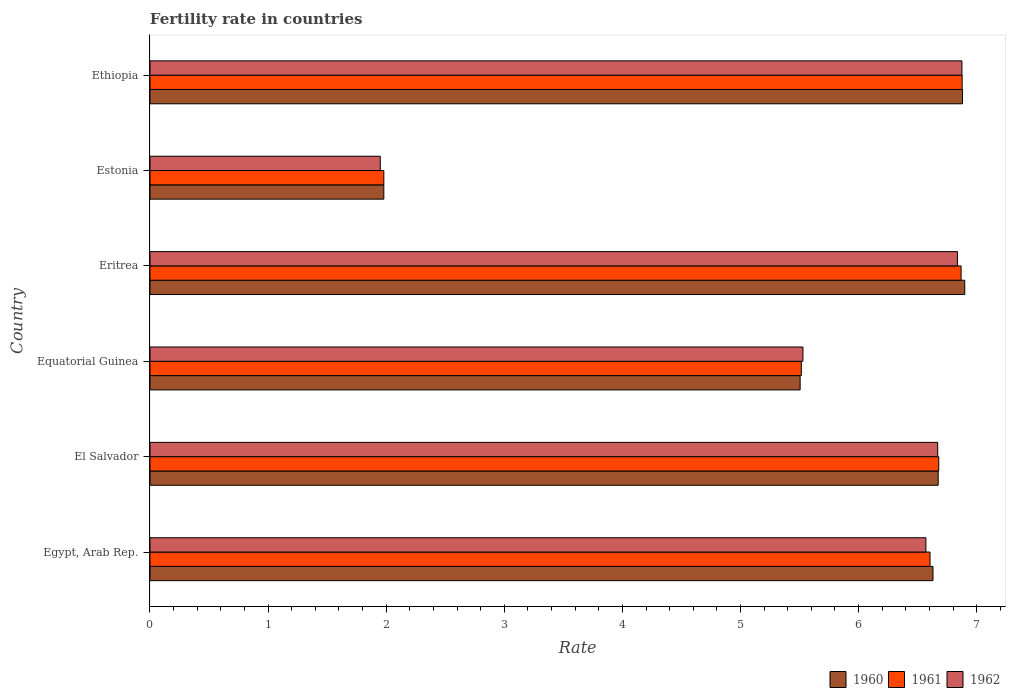Are the number of bars per tick equal to the number of legend labels?
Provide a succinct answer. Yes. How many bars are there on the 6th tick from the top?
Make the answer very short. 3. How many bars are there on the 6th tick from the bottom?
Your answer should be very brief. 3. What is the label of the 3rd group of bars from the top?
Offer a terse response. Eritrea. In how many cases, is the number of bars for a given country not equal to the number of legend labels?
Ensure brevity in your answer.  0. What is the fertility rate in 1960 in Equatorial Guinea?
Keep it short and to the point. 5.5. Across all countries, what is the maximum fertility rate in 1960?
Your response must be concise. 6.9. Across all countries, what is the minimum fertility rate in 1961?
Your answer should be compact. 1.98. In which country was the fertility rate in 1961 maximum?
Keep it short and to the point. Ethiopia. In which country was the fertility rate in 1961 minimum?
Provide a succinct answer. Estonia. What is the total fertility rate in 1962 in the graph?
Give a very brief answer. 34.43. What is the difference between the fertility rate in 1961 in Eritrea and that in Ethiopia?
Keep it short and to the point. -0.01. What is the difference between the fertility rate in 1961 in Equatorial Guinea and the fertility rate in 1962 in Ethiopia?
Offer a very short reply. -1.36. What is the average fertility rate in 1961 per country?
Give a very brief answer. 5.75. What is the difference between the fertility rate in 1960 and fertility rate in 1962 in Estonia?
Ensure brevity in your answer.  0.03. What is the ratio of the fertility rate in 1961 in Eritrea to that in Ethiopia?
Give a very brief answer. 1. Is the fertility rate in 1961 in Eritrea less than that in Estonia?
Your response must be concise. No. Is the difference between the fertility rate in 1960 in Estonia and Ethiopia greater than the difference between the fertility rate in 1962 in Estonia and Ethiopia?
Give a very brief answer. Yes. What is the difference between the highest and the second highest fertility rate in 1960?
Offer a terse response. 0.02. What is the difference between the highest and the lowest fertility rate in 1960?
Provide a succinct answer. 4.92. In how many countries, is the fertility rate in 1961 greater than the average fertility rate in 1961 taken over all countries?
Offer a terse response. 4. Is the sum of the fertility rate in 1960 in El Salvador and Equatorial Guinea greater than the maximum fertility rate in 1962 across all countries?
Ensure brevity in your answer.  Yes. What does the 3rd bar from the top in Egypt, Arab Rep. represents?
Your answer should be compact. 1960. How many countries are there in the graph?
Your answer should be very brief. 6. Are the values on the major ticks of X-axis written in scientific E-notation?
Your answer should be very brief. No. Does the graph contain grids?
Your answer should be compact. No. Where does the legend appear in the graph?
Offer a very short reply. Bottom right. How many legend labels are there?
Offer a very short reply. 3. How are the legend labels stacked?
Provide a succinct answer. Horizontal. What is the title of the graph?
Keep it short and to the point. Fertility rate in countries. What is the label or title of the X-axis?
Keep it short and to the point. Rate. What is the Rate in 1960 in Egypt, Arab Rep.?
Offer a very short reply. 6.63. What is the Rate of 1961 in Egypt, Arab Rep.?
Offer a very short reply. 6.61. What is the Rate of 1962 in Egypt, Arab Rep.?
Your response must be concise. 6.57. What is the Rate of 1960 in El Salvador?
Offer a terse response. 6.67. What is the Rate of 1961 in El Salvador?
Provide a succinct answer. 6.68. What is the Rate of 1962 in El Salvador?
Keep it short and to the point. 6.67. What is the Rate of 1960 in Equatorial Guinea?
Make the answer very short. 5.5. What is the Rate of 1961 in Equatorial Guinea?
Offer a terse response. 5.51. What is the Rate in 1962 in Equatorial Guinea?
Ensure brevity in your answer.  5.53. What is the Rate of 1960 in Eritrea?
Make the answer very short. 6.9. What is the Rate of 1961 in Eritrea?
Offer a very short reply. 6.87. What is the Rate of 1962 in Eritrea?
Your response must be concise. 6.84. What is the Rate in 1960 in Estonia?
Give a very brief answer. 1.98. What is the Rate in 1961 in Estonia?
Give a very brief answer. 1.98. What is the Rate of 1962 in Estonia?
Your answer should be compact. 1.95. What is the Rate in 1960 in Ethiopia?
Make the answer very short. 6.88. What is the Rate of 1961 in Ethiopia?
Provide a succinct answer. 6.88. What is the Rate of 1962 in Ethiopia?
Offer a very short reply. 6.88. Across all countries, what is the maximum Rate in 1960?
Provide a short and direct response. 6.9. Across all countries, what is the maximum Rate in 1961?
Your answer should be very brief. 6.88. Across all countries, what is the maximum Rate in 1962?
Your answer should be compact. 6.88. Across all countries, what is the minimum Rate of 1960?
Provide a short and direct response. 1.98. Across all countries, what is the minimum Rate of 1961?
Your answer should be compact. 1.98. Across all countries, what is the minimum Rate of 1962?
Make the answer very short. 1.95. What is the total Rate in 1960 in the graph?
Your answer should be very brief. 34.57. What is the total Rate in 1961 in the graph?
Your response must be concise. 34.52. What is the total Rate of 1962 in the graph?
Keep it short and to the point. 34.43. What is the difference between the Rate in 1960 in Egypt, Arab Rep. and that in El Salvador?
Offer a very short reply. -0.04. What is the difference between the Rate in 1961 in Egypt, Arab Rep. and that in El Salvador?
Offer a very short reply. -0.07. What is the difference between the Rate in 1962 in Egypt, Arab Rep. and that in El Salvador?
Provide a short and direct response. -0.1. What is the difference between the Rate in 1961 in Egypt, Arab Rep. and that in Equatorial Guinea?
Offer a terse response. 1.09. What is the difference between the Rate of 1962 in Egypt, Arab Rep. and that in Equatorial Guinea?
Your response must be concise. 1.04. What is the difference between the Rate of 1960 in Egypt, Arab Rep. and that in Eritrea?
Offer a very short reply. -0.27. What is the difference between the Rate in 1961 in Egypt, Arab Rep. and that in Eritrea?
Offer a very short reply. -0.26. What is the difference between the Rate of 1962 in Egypt, Arab Rep. and that in Eritrea?
Make the answer very short. -0.27. What is the difference between the Rate of 1960 in Egypt, Arab Rep. and that in Estonia?
Ensure brevity in your answer.  4.65. What is the difference between the Rate of 1961 in Egypt, Arab Rep. and that in Estonia?
Keep it short and to the point. 4.62. What is the difference between the Rate of 1962 in Egypt, Arab Rep. and that in Estonia?
Ensure brevity in your answer.  4.62. What is the difference between the Rate of 1961 in Egypt, Arab Rep. and that in Ethiopia?
Offer a very short reply. -0.27. What is the difference between the Rate in 1962 in Egypt, Arab Rep. and that in Ethiopia?
Provide a succinct answer. -0.3. What is the difference between the Rate of 1960 in El Salvador and that in Equatorial Guinea?
Provide a short and direct response. 1.17. What is the difference between the Rate in 1961 in El Salvador and that in Equatorial Guinea?
Your answer should be compact. 1.16. What is the difference between the Rate in 1962 in El Salvador and that in Equatorial Guinea?
Your answer should be very brief. 1.14. What is the difference between the Rate in 1960 in El Salvador and that in Eritrea?
Offer a terse response. -0.23. What is the difference between the Rate of 1961 in El Salvador and that in Eritrea?
Make the answer very short. -0.19. What is the difference between the Rate in 1962 in El Salvador and that in Eritrea?
Your answer should be very brief. -0.17. What is the difference between the Rate of 1960 in El Salvador and that in Estonia?
Provide a succinct answer. 4.69. What is the difference between the Rate in 1961 in El Salvador and that in Estonia?
Your answer should be compact. 4.7. What is the difference between the Rate of 1962 in El Salvador and that in Estonia?
Keep it short and to the point. 4.72. What is the difference between the Rate in 1960 in El Salvador and that in Ethiopia?
Provide a short and direct response. -0.21. What is the difference between the Rate in 1961 in El Salvador and that in Ethiopia?
Your response must be concise. -0.2. What is the difference between the Rate in 1962 in El Salvador and that in Ethiopia?
Make the answer very short. -0.2. What is the difference between the Rate of 1960 in Equatorial Guinea and that in Eritrea?
Ensure brevity in your answer.  -1.39. What is the difference between the Rate in 1961 in Equatorial Guinea and that in Eritrea?
Your answer should be very brief. -1.35. What is the difference between the Rate of 1962 in Equatorial Guinea and that in Eritrea?
Give a very brief answer. -1.31. What is the difference between the Rate in 1960 in Equatorial Guinea and that in Estonia?
Provide a short and direct response. 3.52. What is the difference between the Rate of 1961 in Equatorial Guinea and that in Estonia?
Your response must be concise. 3.54. What is the difference between the Rate of 1962 in Equatorial Guinea and that in Estonia?
Give a very brief answer. 3.58. What is the difference between the Rate in 1960 in Equatorial Guinea and that in Ethiopia?
Provide a succinct answer. -1.38. What is the difference between the Rate in 1961 in Equatorial Guinea and that in Ethiopia?
Make the answer very short. -1.36. What is the difference between the Rate of 1962 in Equatorial Guinea and that in Ethiopia?
Keep it short and to the point. -1.35. What is the difference between the Rate in 1960 in Eritrea and that in Estonia?
Offer a very short reply. 4.92. What is the difference between the Rate of 1961 in Eritrea and that in Estonia?
Keep it short and to the point. 4.89. What is the difference between the Rate of 1962 in Eritrea and that in Estonia?
Keep it short and to the point. 4.89. What is the difference between the Rate in 1960 in Eritrea and that in Ethiopia?
Ensure brevity in your answer.  0.02. What is the difference between the Rate of 1961 in Eritrea and that in Ethiopia?
Your answer should be compact. -0.01. What is the difference between the Rate in 1962 in Eritrea and that in Ethiopia?
Your answer should be compact. -0.04. What is the difference between the Rate in 1961 in Estonia and that in Ethiopia?
Give a very brief answer. -4.9. What is the difference between the Rate in 1962 in Estonia and that in Ethiopia?
Provide a short and direct response. -4.92. What is the difference between the Rate in 1960 in Egypt, Arab Rep. and the Rate in 1961 in El Salvador?
Keep it short and to the point. -0.05. What is the difference between the Rate of 1960 in Egypt, Arab Rep. and the Rate of 1962 in El Salvador?
Your answer should be compact. -0.04. What is the difference between the Rate of 1961 in Egypt, Arab Rep. and the Rate of 1962 in El Salvador?
Your answer should be compact. -0.07. What is the difference between the Rate of 1960 in Egypt, Arab Rep. and the Rate of 1961 in Equatorial Guinea?
Give a very brief answer. 1.11. What is the difference between the Rate in 1960 in Egypt, Arab Rep. and the Rate in 1962 in Equatorial Guinea?
Ensure brevity in your answer.  1.1. What is the difference between the Rate in 1961 in Egypt, Arab Rep. and the Rate in 1962 in Equatorial Guinea?
Your response must be concise. 1.08. What is the difference between the Rate in 1960 in Egypt, Arab Rep. and the Rate in 1961 in Eritrea?
Your answer should be very brief. -0.24. What is the difference between the Rate in 1960 in Egypt, Arab Rep. and the Rate in 1962 in Eritrea?
Offer a very short reply. -0.21. What is the difference between the Rate of 1961 in Egypt, Arab Rep. and the Rate of 1962 in Eritrea?
Your answer should be compact. -0.23. What is the difference between the Rate of 1960 in Egypt, Arab Rep. and the Rate of 1961 in Estonia?
Make the answer very short. 4.65. What is the difference between the Rate in 1960 in Egypt, Arab Rep. and the Rate in 1962 in Estonia?
Provide a succinct answer. 4.68. What is the difference between the Rate of 1961 in Egypt, Arab Rep. and the Rate of 1962 in Estonia?
Provide a succinct answer. 4.66. What is the difference between the Rate of 1960 in Egypt, Arab Rep. and the Rate of 1961 in Ethiopia?
Make the answer very short. -0.25. What is the difference between the Rate in 1960 in Egypt, Arab Rep. and the Rate in 1962 in Ethiopia?
Offer a terse response. -0.24. What is the difference between the Rate of 1961 in Egypt, Arab Rep. and the Rate of 1962 in Ethiopia?
Offer a very short reply. -0.27. What is the difference between the Rate in 1960 in El Salvador and the Rate in 1961 in Equatorial Guinea?
Provide a succinct answer. 1.16. What is the difference between the Rate of 1960 in El Salvador and the Rate of 1962 in Equatorial Guinea?
Keep it short and to the point. 1.15. What is the difference between the Rate of 1961 in El Salvador and the Rate of 1962 in Equatorial Guinea?
Provide a succinct answer. 1.15. What is the difference between the Rate in 1960 in El Salvador and the Rate in 1961 in Eritrea?
Provide a succinct answer. -0.19. What is the difference between the Rate in 1960 in El Salvador and the Rate in 1962 in Eritrea?
Offer a very short reply. -0.16. What is the difference between the Rate in 1961 in El Salvador and the Rate in 1962 in Eritrea?
Your response must be concise. -0.16. What is the difference between the Rate of 1960 in El Salvador and the Rate of 1961 in Estonia?
Ensure brevity in your answer.  4.69. What is the difference between the Rate of 1960 in El Salvador and the Rate of 1962 in Estonia?
Offer a terse response. 4.72. What is the difference between the Rate in 1961 in El Salvador and the Rate in 1962 in Estonia?
Your response must be concise. 4.73. What is the difference between the Rate in 1960 in El Salvador and the Rate in 1961 in Ethiopia?
Offer a terse response. -0.2. What is the difference between the Rate in 1960 in El Salvador and the Rate in 1962 in Ethiopia?
Offer a terse response. -0.2. What is the difference between the Rate in 1961 in El Salvador and the Rate in 1962 in Ethiopia?
Ensure brevity in your answer.  -0.2. What is the difference between the Rate in 1960 in Equatorial Guinea and the Rate in 1961 in Eritrea?
Offer a terse response. -1.36. What is the difference between the Rate in 1960 in Equatorial Guinea and the Rate in 1962 in Eritrea?
Give a very brief answer. -1.33. What is the difference between the Rate of 1961 in Equatorial Guinea and the Rate of 1962 in Eritrea?
Make the answer very short. -1.32. What is the difference between the Rate in 1960 in Equatorial Guinea and the Rate in 1961 in Estonia?
Offer a terse response. 3.52. What is the difference between the Rate in 1960 in Equatorial Guinea and the Rate in 1962 in Estonia?
Keep it short and to the point. 3.56. What is the difference between the Rate in 1961 in Equatorial Guinea and the Rate in 1962 in Estonia?
Provide a succinct answer. 3.56. What is the difference between the Rate of 1960 in Equatorial Guinea and the Rate of 1961 in Ethiopia?
Provide a succinct answer. -1.37. What is the difference between the Rate in 1960 in Equatorial Guinea and the Rate in 1962 in Ethiopia?
Provide a succinct answer. -1.37. What is the difference between the Rate of 1961 in Equatorial Guinea and the Rate of 1962 in Ethiopia?
Provide a short and direct response. -1.36. What is the difference between the Rate of 1960 in Eritrea and the Rate of 1961 in Estonia?
Your answer should be compact. 4.92. What is the difference between the Rate in 1960 in Eritrea and the Rate in 1962 in Estonia?
Offer a very short reply. 4.95. What is the difference between the Rate of 1961 in Eritrea and the Rate of 1962 in Estonia?
Your answer should be compact. 4.92. What is the difference between the Rate in 1960 in Eritrea and the Rate in 1961 in Ethiopia?
Your answer should be compact. 0.02. What is the difference between the Rate in 1960 in Eritrea and the Rate in 1962 in Ethiopia?
Your answer should be compact. 0.02. What is the difference between the Rate of 1961 in Eritrea and the Rate of 1962 in Ethiopia?
Your answer should be very brief. -0.01. What is the difference between the Rate in 1960 in Estonia and the Rate in 1961 in Ethiopia?
Your answer should be compact. -4.9. What is the difference between the Rate of 1960 in Estonia and the Rate of 1962 in Ethiopia?
Offer a very short reply. -4.89. What is the difference between the Rate in 1961 in Estonia and the Rate in 1962 in Ethiopia?
Ensure brevity in your answer.  -4.89. What is the average Rate of 1960 per country?
Your answer should be compact. 5.76. What is the average Rate in 1961 per country?
Your answer should be very brief. 5.75. What is the average Rate of 1962 per country?
Make the answer very short. 5.74. What is the difference between the Rate in 1960 and Rate in 1961 in Egypt, Arab Rep.?
Your answer should be compact. 0.03. What is the difference between the Rate of 1961 and Rate of 1962 in Egypt, Arab Rep.?
Give a very brief answer. 0.04. What is the difference between the Rate of 1960 and Rate of 1961 in El Salvador?
Offer a terse response. -0.01. What is the difference between the Rate in 1960 and Rate in 1962 in El Salvador?
Keep it short and to the point. 0. What is the difference between the Rate in 1961 and Rate in 1962 in El Salvador?
Your answer should be compact. 0.01. What is the difference between the Rate of 1960 and Rate of 1961 in Equatorial Guinea?
Offer a terse response. -0.01. What is the difference between the Rate in 1960 and Rate in 1962 in Equatorial Guinea?
Offer a terse response. -0.02. What is the difference between the Rate in 1961 and Rate in 1962 in Equatorial Guinea?
Offer a terse response. -0.01. What is the difference between the Rate in 1960 and Rate in 1961 in Eritrea?
Offer a terse response. 0.03. What is the difference between the Rate of 1960 and Rate of 1962 in Eritrea?
Your answer should be very brief. 0.06. What is the difference between the Rate of 1961 and Rate of 1962 in Eritrea?
Keep it short and to the point. 0.03. What is the difference between the Rate of 1960 and Rate of 1962 in Estonia?
Make the answer very short. 0.03. What is the difference between the Rate of 1961 and Rate of 1962 in Estonia?
Provide a succinct answer. 0.03. What is the difference between the Rate in 1960 and Rate in 1961 in Ethiopia?
Ensure brevity in your answer.  0. What is the difference between the Rate in 1960 and Rate in 1962 in Ethiopia?
Keep it short and to the point. 0.01. What is the difference between the Rate in 1961 and Rate in 1962 in Ethiopia?
Offer a terse response. 0. What is the ratio of the Rate of 1961 in Egypt, Arab Rep. to that in El Salvador?
Provide a short and direct response. 0.99. What is the ratio of the Rate of 1960 in Egypt, Arab Rep. to that in Equatorial Guinea?
Provide a succinct answer. 1.2. What is the ratio of the Rate of 1961 in Egypt, Arab Rep. to that in Equatorial Guinea?
Provide a short and direct response. 1.2. What is the ratio of the Rate in 1962 in Egypt, Arab Rep. to that in Equatorial Guinea?
Your answer should be very brief. 1.19. What is the ratio of the Rate in 1960 in Egypt, Arab Rep. to that in Eritrea?
Provide a short and direct response. 0.96. What is the ratio of the Rate of 1961 in Egypt, Arab Rep. to that in Eritrea?
Your answer should be compact. 0.96. What is the ratio of the Rate of 1962 in Egypt, Arab Rep. to that in Eritrea?
Offer a terse response. 0.96. What is the ratio of the Rate of 1960 in Egypt, Arab Rep. to that in Estonia?
Your answer should be very brief. 3.35. What is the ratio of the Rate of 1961 in Egypt, Arab Rep. to that in Estonia?
Provide a short and direct response. 3.34. What is the ratio of the Rate of 1962 in Egypt, Arab Rep. to that in Estonia?
Make the answer very short. 3.37. What is the ratio of the Rate of 1960 in Egypt, Arab Rep. to that in Ethiopia?
Your response must be concise. 0.96. What is the ratio of the Rate in 1961 in Egypt, Arab Rep. to that in Ethiopia?
Provide a succinct answer. 0.96. What is the ratio of the Rate of 1962 in Egypt, Arab Rep. to that in Ethiopia?
Your answer should be very brief. 0.96. What is the ratio of the Rate in 1960 in El Salvador to that in Equatorial Guinea?
Your response must be concise. 1.21. What is the ratio of the Rate of 1961 in El Salvador to that in Equatorial Guinea?
Your response must be concise. 1.21. What is the ratio of the Rate of 1962 in El Salvador to that in Equatorial Guinea?
Offer a terse response. 1.21. What is the ratio of the Rate in 1960 in El Salvador to that in Eritrea?
Keep it short and to the point. 0.97. What is the ratio of the Rate of 1961 in El Salvador to that in Eritrea?
Keep it short and to the point. 0.97. What is the ratio of the Rate in 1962 in El Salvador to that in Eritrea?
Give a very brief answer. 0.98. What is the ratio of the Rate in 1960 in El Salvador to that in Estonia?
Make the answer very short. 3.37. What is the ratio of the Rate in 1961 in El Salvador to that in Estonia?
Your answer should be compact. 3.37. What is the ratio of the Rate in 1962 in El Salvador to that in Estonia?
Your answer should be compact. 3.42. What is the ratio of the Rate of 1960 in El Salvador to that in Ethiopia?
Ensure brevity in your answer.  0.97. What is the ratio of the Rate of 1961 in El Salvador to that in Ethiopia?
Provide a short and direct response. 0.97. What is the ratio of the Rate in 1962 in El Salvador to that in Ethiopia?
Offer a terse response. 0.97. What is the ratio of the Rate of 1960 in Equatorial Guinea to that in Eritrea?
Your answer should be very brief. 0.8. What is the ratio of the Rate in 1961 in Equatorial Guinea to that in Eritrea?
Make the answer very short. 0.8. What is the ratio of the Rate in 1962 in Equatorial Guinea to that in Eritrea?
Provide a short and direct response. 0.81. What is the ratio of the Rate of 1960 in Equatorial Guinea to that in Estonia?
Your answer should be very brief. 2.78. What is the ratio of the Rate in 1961 in Equatorial Guinea to that in Estonia?
Your answer should be very brief. 2.79. What is the ratio of the Rate of 1962 in Equatorial Guinea to that in Estonia?
Ensure brevity in your answer.  2.84. What is the ratio of the Rate in 1960 in Equatorial Guinea to that in Ethiopia?
Make the answer very short. 0.8. What is the ratio of the Rate of 1961 in Equatorial Guinea to that in Ethiopia?
Your response must be concise. 0.8. What is the ratio of the Rate in 1962 in Equatorial Guinea to that in Ethiopia?
Keep it short and to the point. 0.8. What is the ratio of the Rate of 1960 in Eritrea to that in Estonia?
Keep it short and to the point. 3.48. What is the ratio of the Rate in 1961 in Eritrea to that in Estonia?
Make the answer very short. 3.47. What is the ratio of the Rate of 1962 in Eritrea to that in Estonia?
Make the answer very short. 3.51. What is the ratio of the Rate in 1961 in Eritrea to that in Ethiopia?
Make the answer very short. 1. What is the ratio of the Rate in 1960 in Estonia to that in Ethiopia?
Your response must be concise. 0.29. What is the ratio of the Rate in 1961 in Estonia to that in Ethiopia?
Your response must be concise. 0.29. What is the ratio of the Rate in 1962 in Estonia to that in Ethiopia?
Provide a succinct answer. 0.28. What is the difference between the highest and the second highest Rate in 1960?
Keep it short and to the point. 0.02. What is the difference between the highest and the second highest Rate in 1961?
Offer a terse response. 0.01. What is the difference between the highest and the second highest Rate in 1962?
Offer a terse response. 0.04. What is the difference between the highest and the lowest Rate in 1960?
Make the answer very short. 4.92. What is the difference between the highest and the lowest Rate of 1961?
Provide a succinct answer. 4.9. What is the difference between the highest and the lowest Rate in 1962?
Keep it short and to the point. 4.92. 